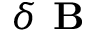Convert formula to latex. <formula><loc_0><loc_0><loc_500><loc_500>\delta B</formula> 